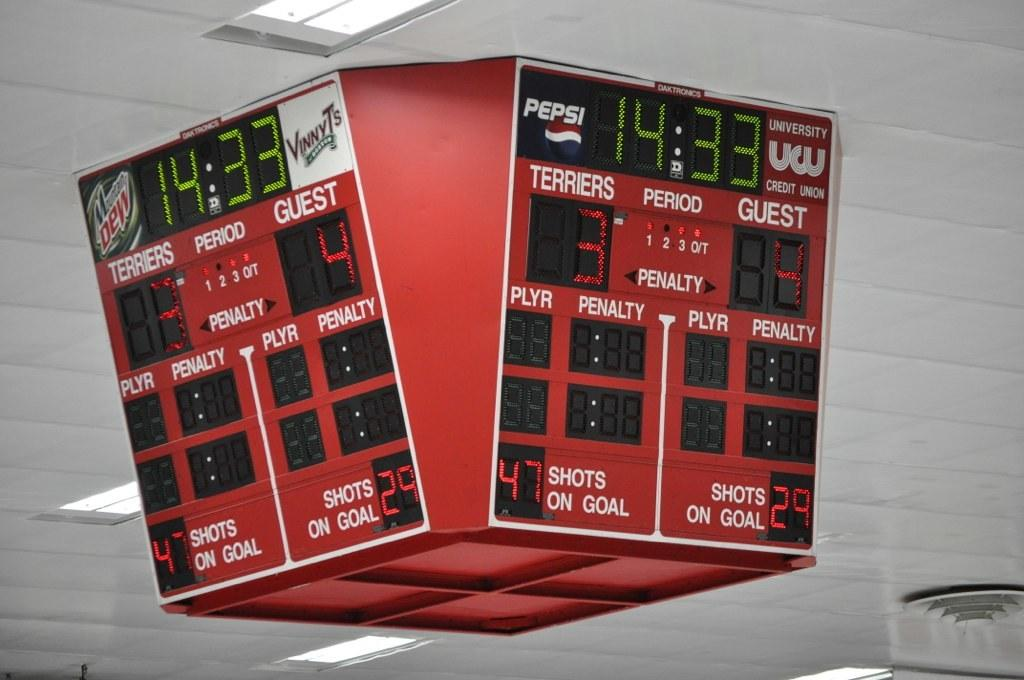Provide a one-sentence caption for the provided image. A scoreboard shows the score is Terriers 3, Guest 4. 